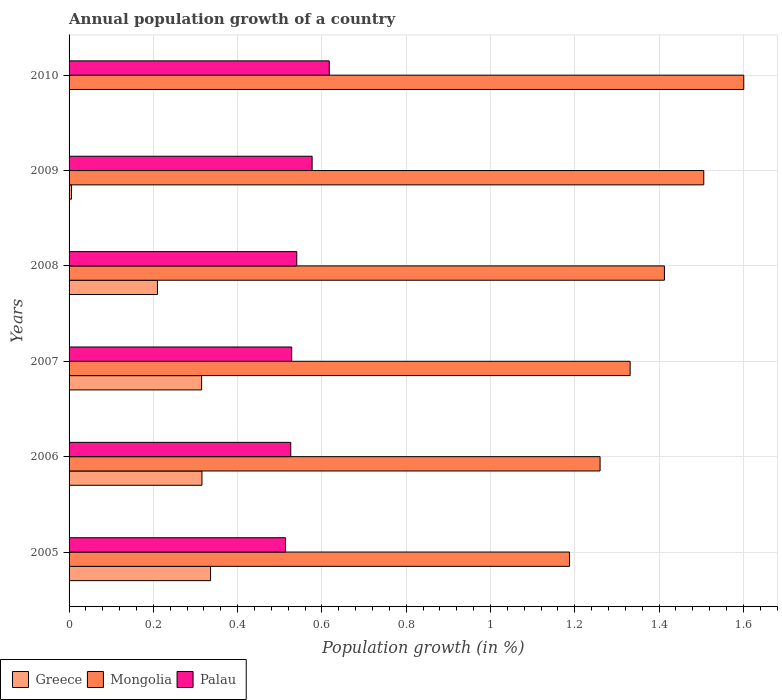How many groups of bars are there?
Provide a succinct answer. 6. How many bars are there on the 2nd tick from the bottom?
Offer a terse response. 3. In how many cases, is the number of bars for a given year not equal to the number of legend labels?
Your answer should be compact. 1. What is the annual population growth in Mongolia in 2010?
Offer a very short reply. 1.6. Across all years, what is the maximum annual population growth in Mongolia?
Your response must be concise. 1.6. Across all years, what is the minimum annual population growth in Mongolia?
Give a very brief answer. 1.19. What is the total annual population growth in Mongolia in the graph?
Make the answer very short. 8.3. What is the difference between the annual population growth in Greece in 2006 and that in 2008?
Ensure brevity in your answer.  0.11. What is the difference between the annual population growth in Palau in 2010 and the annual population growth in Mongolia in 2008?
Provide a short and direct response. -0.8. What is the average annual population growth in Mongolia per year?
Offer a very short reply. 1.38. In the year 2005, what is the difference between the annual population growth in Greece and annual population growth in Mongolia?
Offer a terse response. -0.85. In how many years, is the annual population growth in Greece greater than 0.48000000000000004 %?
Your answer should be very brief. 0. What is the ratio of the annual population growth in Greece in 2005 to that in 2006?
Make the answer very short. 1.06. Is the annual population growth in Palau in 2005 less than that in 2008?
Ensure brevity in your answer.  Yes. What is the difference between the highest and the second highest annual population growth in Greece?
Provide a short and direct response. 0.02. What is the difference between the highest and the lowest annual population growth in Palau?
Your answer should be compact. 0.1. In how many years, is the annual population growth in Palau greater than the average annual population growth in Palau taken over all years?
Offer a terse response. 2. Is the sum of the annual population growth in Mongolia in 2006 and 2009 greater than the maximum annual population growth in Palau across all years?
Keep it short and to the point. Yes. Are all the bars in the graph horizontal?
Offer a very short reply. Yes. What is the difference between two consecutive major ticks on the X-axis?
Your answer should be compact. 0.2. Are the values on the major ticks of X-axis written in scientific E-notation?
Keep it short and to the point. No. How are the legend labels stacked?
Give a very brief answer. Horizontal. What is the title of the graph?
Keep it short and to the point. Annual population growth of a country. Does "Malta" appear as one of the legend labels in the graph?
Offer a very short reply. No. What is the label or title of the X-axis?
Make the answer very short. Population growth (in %). What is the label or title of the Y-axis?
Provide a succinct answer. Years. What is the Population growth (in %) in Greece in 2005?
Offer a terse response. 0.34. What is the Population growth (in %) in Mongolia in 2005?
Make the answer very short. 1.19. What is the Population growth (in %) of Palau in 2005?
Offer a terse response. 0.51. What is the Population growth (in %) of Greece in 2006?
Offer a very short reply. 0.32. What is the Population growth (in %) of Mongolia in 2006?
Keep it short and to the point. 1.26. What is the Population growth (in %) of Palau in 2006?
Ensure brevity in your answer.  0.53. What is the Population growth (in %) in Greece in 2007?
Your answer should be very brief. 0.31. What is the Population growth (in %) in Mongolia in 2007?
Provide a succinct answer. 1.33. What is the Population growth (in %) in Palau in 2007?
Provide a succinct answer. 0.53. What is the Population growth (in %) of Greece in 2008?
Give a very brief answer. 0.21. What is the Population growth (in %) in Mongolia in 2008?
Your answer should be compact. 1.41. What is the Population growth (in %) of Palau in 2008?
Provide a succinct answer. 0.54. What is the Population growth (in %) in Greece in 2009?
Make the answer very short. 0.01. What is the Population growth (in %) of Mongolia in 2009?
Offer a terse response. 1.51. What is the Population growth (in %) of Palau in 2009?
Offer a very short reply. 0.58. What is the Population growth (in %) in Greece in 2010?
Your answer should be very brief. 0. What is the Population growth (in %) of Mongolia in 2010?
Your answer should be compact. 1.6. What is the Population growth (in %) of Palau in 2010?
Your answer should be very brief. 0.62. Across all years, what is the maximum Population growth (in %) in Greece?
Your response must be concise. 0.34. Across all years, what is the maximum Population growth (in %) of Mongolia?
Give a very brief answer. 1.6. Across all years, what is the maximum Population growth (in %) of Palau?
Give a very brief answer. 0.62. Across all years, what is the minimum Population growth (in %) of Mongolia?
Your response must be concise. 1.19. Across all years, what is the minimum Population growth (in %) of Palau?
Provide a short and direct response. 0.51. What is the total Population growth (in %) in Greece in the graph?
Your answer should be very brief. 1.18. What is the total Population growth (in %) in Mongolia in the graph?
Keep it short and to the point. 8.3. What is the total Population growth (in %) of Palau in the graph?
Your response must be concise. 3.3. What is the difference between the Population growth (in %) in Greece in 2005 and that in 2006?
Your answer should be very brief. 0.02. What is the difference between the Population growth (in %) of Mongolia in 2005 and that in 2006?
Make the answer very short. -0.07. What is the difference between the Population growth (in %) in Palau in 2005 and that in 2006?
Give a very brief answer. -0.01. What is the difference between the Population growth (in %) in Greece in 2005 and that in 2007?
Make the answer very short. 0.02. What is the difference between the Population growth (in %) of Mongolia in 2005 and that in 2007?
Give a very brief answer. -0.14. What is the difference between the Population growth (in %) of Palau in 2005 and that in 2007?
Keep it short and to the point. -0.01. What is the difference between the Population growth (in %) in Greece in 2005 and that in 2008?
Your answer should be compact. 0.13. What is the difference between the Population growth (in %) in Mongolia in 2005 and that in 2008?
Offer a terse response. -0.23. What is the difference between the Population growth (in %) in Palau in 2005 and that in 2008?
Provide a short and direct response. -0.03. What is the difference between the Population growth (in %) of Greece in 2005 and that in 2009?
Your answer should be very brief. 0.33. What is the difference between the Population growth (in %) in Mongolia in 2005 and that in 2009?
Ensure brevity in your answer.  -0.32. What is the difference between the Population growth (in %) in Palau in 2005 and that in 2009?
Your answer should be very brief. -0.06. What is the difference between the Population growth (in %) of Mongolia in 2005 and that in 2010?
Your response must be concise. -0.41. What is the difference between the Population growth (in %) of Palau in 2005 and that in 2010?
Your answer should be compact. -0.1. What is the difference between the Population growth (in %) of Greece in 2006 and that in 2007?
Your response must be concise. 0. What is the difference between the Population growth (in %) in Mongolia in 2006 and that in 2007?
Your answer should be very brief. -0.07. What is the difference between the Population growth (in %) in Palau in 2006 and that in 2007?
Your response must be concise. -0. What is the difference between the Population growth (in %) in Greece in 2006 and that in 2008?
Make the answer very short. 0.11. What is the difference between the Population growth (in %) in Mongolia in 2006 and that in 2008?
Your response must be concise. -0.15. What is the difference between the Population growth (in %) of Palau in 2006 and that in 2008?
Make the answer very short. -0.01. What is the difference between the Population growth (in %) of Greece in 2006 and that in 2009?
Provide a succinct answer. 0.31. What is the difference between the Population growth (in %) of Mongolia in 2006 and that in 2009?
Provide a short and direct response. -0.25. What is the difference between the Population growth (in %) in Palau in 2006 and that in 2009?
Make the answer very short. -0.05. What is the difference between the Population growth (in %) in Mongolia in 2006 and that in 2010?
Give a very brief answer. -0.34. What is the difference between the Population growth (in %) in Palau in 2006 and that in 2010?
Your answer should be compact. -0.09. What is the difference between the Population growth (in %) in Greece in 2007 and that in 2008?
Make the answer very short. 0.1. What is the difference between the Population growth (in %) in Mongolia in 2007 and that in 2008?
Make the answer very short. -0.08. What is the difference between the Population growth (in %) of Palau in 2007 and that in 2008?
Offer a terse response. -0.01. What is the difference between the Population growth (in %) of Greece in 2007 and that in 2009?
Offer a very short reply. 0.31. What is the difference between the Population growth (in %) in Mongolia in 2007 and that in 2009?
Keep it short and to the point. -0.17. What is the difference between the Population growth (in %) of Palau in 2007 and that in 2009?
Provide a succinct answer. -0.05. What is the difference between the Population growth (in %) in Mongolia in 2007 and that in 2010?
Ensure brevity in your answer.  -0.27. What is the difference between the Population growth (in %) in Palau in 2007 and that in 2010?
Offer a terse response. -0.09. What is the difference between the Population growth (in %) of Greece in 2008 and that in 2009?
Your answer should be compact. 0.2. What is the difference between the Population growth (in %) of Mongolia in 2008 and that in 2009?
Offer a terse response. -0.09. What is the difference between the Population growth (in %) in Palau in 2008 and that in 2009?
Ensure brevity in your answer.  -0.04. What is the difference between the Population growth (in %) in Mongolia in 2008 and that in 2010?
Make the answer very short. -0.19. What is the difference between the Population growth (in %) of Palau in 2008 and that in 2010?
Offer a terse response. -0.08. What is the difference between the Population growth (in %) of Mongolia in 2009 and that in 2010?
Keep it short and to the point. -0.09. What is the difference between the Population growth (in %) of Palau in 2009 and that in 2010?
Your response must be concise. -0.04. What is the difference between the Population growth (in %) in Greece in 2005 and the Population growth (in %) in Mongolia in 2006?
Ensure brevity in your answer.  -0.92. What is the difference between the Population growth (in %) of Greece in 2005 and the Population growth (in %) of Palau in 2006?
Offer a very short reply. -0.19. What is the difference between the Population growth (in %) of Mongolia in 2005 and the Population growth (in %) of Palau in 2006?
Offer a very short reply. 0.66. What is the difference between the Population growth (in %) of Greece in 2005 and the Population growth (in %) of Mongolia in 2007?
Your answer should be compact. -1. What is the difference between the Population growth (in %) of Greece in 2005 and the Population growth (in %) of Palau in 2007?
Offer a very short reply. -0.19. What is the difference between the Population growth (in %) in Mongolia in 2005 and the Population growth (in %) in Palau in 2007?
Make the answer very short. 0.66. What is the difference between the Population growth (in %) in Greece in 2005 and the Population growth (in %) in Mongolia in 2008?
Give a very brief answer. -1.08. What is the difference between the Population growth (in %) of Greece in 2005 and the Population growth (in %) of Palau in 2008?
Make the answer very short. -0.2. What is the difference between the Population growth (in %) of Mongolia in 2005 and the Population growth (in %) of Palau in 2008?
Your answer should be very brief. 0.65. What is the difference between the Population growth (in %) in Greece in 2005 and the Population growth (in %) in Mongolia in 2009?
Your response must be concise. -1.17. What is the difference between the Population growth (in %) of Greece in 2005 and the Population growth (in %) of Palau in 2009?
Your response must be concise. -0.24. What is the difference between the Population growth (in %) of Mongolia in 2005 and the Population growth (in %) of Palau in 2009?
Give a very brief answer. 0.61. What is the difference between the Population growth (in %) in Greece in 2005 and the Population growth (in %) in Mongolia in 2010?
Make the answer very short. -1.27. What is the difference between the Population growth (in %) in Greece in 2005 and the Population growth (in %) in Palau in 2010?
Provide a succinct answer. -0.28. What is the difference between the Population growth (in %) in Mongolia in 2005 and the Population growth (in %) in Palau in 2010?
Keep it short and to the point. 0.57. What is the difference between the Population growth (in %) in Greece in 2006 and the Population growth (in %) in Mongolia in 2007?
Provide a succinct answer. -1.02. What is the difference between the Population growth (in %) of Greece in 2006 and the Population growth (in %) of Palau in 2007?
Keep it short and to the point. -0.21. What is the difference between the Population growth (in %) of Mongolia in 2006 and the Population growth (in %) of Palau in 2007?
Provide a short and direct response. 0.73. What is the difference between the Population growth (in %) in Greece in 2006 and the Population growth (in %) in Mongolia in 2008?
Offer a very short reply. -1.1. What is the difference between the Population growth (in %) in Greece in 2006 and the Population growth (in %) in Palau in 2008?
Offer a terse response. -0.23. What is the difference between the Population growth (in %) in Mongolia in 2006 and the Population growth (in %) in Palau in 2008?
Your answer should be very brief. 0.72. What is the difference between the Population growth (in %) of Greece in 2006 and the Population growth (in %) of Mongolia in 2009?
Offer a very short reply. -1.19. What is the difference between the Population growth (in %) of Greece in 2006 and the Population growth (in %) of Palau in 2009?
Offer a terse response. -0.26. What is the difference between the Population growth (in %) of Mongolia in 2006 and the Population growth (in %) of Palau in 2009?
Make the answer very short. 0.68. What is the difference between the Population growth (in %) of Greece in 2006 and the Population growth (in %) of Mongolia in 2010?
Keep it short and to the point. -1.29. What is the difference between the Population growth (in %) in Greece in 2006 and the Population growth (in %) in Palau in 2010?
Keep it short and to the point. -0.3. What is the difference between the Population growth (in %) in Mongolia in 2006 and the Population growth (in %) in Palau in 2010?
Keep it short and to the point. 0.64. What is the difference between the Population growth (in %) in Greece in 2007 and the Population growth (in %) in Mongolia in 2008?
Make the answer very short. -1.1. What is the difference between the Population growth (in %) in Greece in 2007 and the Population growth (in %) in Palau in 2008?
Your answer should be very brief. -0.23. What is the difference between the Population growth (in %) of Mongolia in 2007 and the Population growth (in %) of Palau in 2008?
Make the answer very short. 0.79. What is the difference between the Population growth (in %) of Greece in 2007 and the Population growth (in %) of Mongolia in 2009?
Give a very brief answer. -1.19. What is the difference between the Population growth (in %) in Greece in 2007 and the Population growth (in %) in Palau in 2009?
Your response must be concise. -0.26. What is the difference between the Population growth (in %) in Mongolia in 2007 and the Population growth (in %) in Palau in 2009?
Keep it short and to the point. 0.75. What is the difference between the Population growth (in %) in Greece in 2007 and the Population growth (in %) in Mongolia in 2010?
Make the answer very short. -1.29. What is the difference between the Population growth (in %) of Greece in 2007 and the Population growth (in %) of Palau in 2010?
Your answer should be compact. -0.3. What is the difference between the Population growth (in %) in Mongolia in 2007 and the Population growth (in %) in Palau in 2010?
Provide a succinct answer. 0.71. What is the difference between the Population growth (in %) of Greece in 2008 and the Population growth (in %) of Mongolia in 2009?
Provide a succinct answer. -1.3. What is the difference between the Population growth (in %) in Greece in 2008 and the Population growth (in %) in Palau in 2009?
Provide a succinct answer. -0.37. What is the difference between the Population growth (in %) of Mongolia in 2008 and the Population growth (in %) of Palau in 2009?
Offer a terse response. 0.84. What is the difference between the Population growth (in %) in Greece in 2008 and the Population growth (in %) in Mongolia in 2010?
Your response must be concise. -1.39. What is the difference between the Population growth (in %) of Greece in 2008 and the Population growth (in %) of Palau in 2010?
Offer a very short reply. -0.41. What is the difference between the Population growth (in %) in Mongolia in 2008 and the Population growth (in %) in Palau in 2010?
Your response must be concise. 0.8. What is the difference between the Population growth (in %) of Greece in 2009 and the Population growth (in %) of Mongolia in 2010?
Give a very brief answer. -1.6. What is the difference between the Population growth (in %) in Greece in 2009 and the Population growth (in %) in Palau in 2010?
Provide a succinct answer. -0.61. What is the difference between the Population growth (in %) of Mongolia in 2009 and the Population growth (in %) of Palau in 2010?
Your response must be concise. 0.89. What is the average Population growth (in %) of Greece per year?
Keep it short and to the point. 0.2. What is the average Population growth (in %) in Mongolia per year?
Your response must be concise. 1.38. What is the average Population growth (in %) in Palau per year?
Offer a terse response. 0.55. In the year 2005, what is the difference between the Population growth (in %) of Greece and Population growth (in %) of Mongolia?
Offer a terse response. -0.85. In the year 2005, what is the difference between the Population growth (in %) of Greece and Population growth (in %) of Palau?
Provide a succinct answer. -0.18. In the year 2005, what is the difference between the Population growth (in %) of Mongolia and Population growth (in %) of Palau?
Keep it short and to the point. 0.67. In the year 2006, what is the difference between the Population growth (in %) of Greece and Population growth (in %) of Mongolia?
Give a very brief answer. -0.94. In the year 2006, what is the difference between the Population growth (in %) in Greece and Population growth (in %) in Palau?
Your response must be concise. -0.21. In the year 2006, what is the difference between the Population growth (in %) of Mongolia and Population growth (in %) of Palau?
Offer a terse response. 0.73. In the year 2007, what is the difference between the Population growth (in %) in Greece and Population growth (in %) in Mongolia?
Make the answer very short. -1.02. In the year 2007, what is the difference between the Population growth (in %) of Greece and Population growth (in %) of Palau?
Your response must be concise. -0.21. In the year 2007, what is the difference between the Population growth (in %) in Mongolia and Population growth (in %) in Palau?
Provide a succinct answer. 0.8. In the year 2008, what is the difference between the Population growth (in %) of Greece and Population growth (in %) of Mongolia?
Provide a short and direct response. -1.2. In the year 2008, what is the difference between the Population growth (in %) in Greece and Population growth (in %) in Palau?
Give a very brief answer. -0.33. In the year 2008, what is the difference between the Population growth (in %) of Mongolia and Population growth (in %) of Palau?
Your answer should be very brief. 0.87. In the year 2009, what is the difference between the Population growth (in %) in Greece and Population growth (in %) in Mongolia?
Ensure brevity in your answer.  -1.5. In the year 2009, what is the difference between the Population growth (in %) of Greece and Population growth (in %) of Palau?
Give a very brief answer. -0.57. In the year 2009, what is the difference between the Population growth (in %) of Mongolia and Population growth (in %) of Palau?
Provide a succinct answer. 0.93. In the year 2010, what is the difference between the Population growth (in %) of Mongolia and Population growth (in %) of Palau?
Your answer should be very brief. 0.98. What is the ratio of the Population growth (in %) of Greece in 2005 to that in 2006?
Your answer should be compact. 1.06. What is the ratio of the Population growth (in %) of Mongolia in 2005 to that in 2006?
Provide a succinct answer. 0.94. What is the ratio of the Population growth (in %) in Palau in 2005 to that in 2006?
Keep it short and to the point. 0.98. What is the ratio of the Population growth (in %) in Greece in 2005 to that in 2007?
Your answer should be compact. 1.07. What is the ratio of the Population growth (in %) of Mongolia in 2005 to that in 2007?
Provide a short and direct response. 0.89. What is the ratio of the Population growth (in %) of Palau in 2005 to that in 2007?
Ensure brevity in your answer.  0.97. What is the ratio of the Population growth (in %) in Greece in 2005 to that in 2008?
Offer a very short reply. 1.6. What is the ratio of the Population growth (in %) of Mongolia in 2005 to that in 2008?
Your response must be concise. 0.84. What is the ratio of the Population growth (in %) in Palau in 2005 to that in 2008?
Your answer should be compact. 0.95. What is the ratio of the Population growth (in %) in Greece in 2005 to that in 2009?
Keep it short and to the point. 58.14. What is the ratio of the Population growth (in %) of Mongolia in 2005 to that in 2009?
Your response must be concise. 0.79. What is the ratio of the Population growth (in %) of Palau in 2005 to that in 2009?
Your answer should be very brief. 0.89. What is the ratio of the Population growth (in %) of Mongolia in 2005 to that in 2010?
Provide a succinct answer. 0.74. What is the ratio of the Population growth (in %) of Palau in 2005 to that in 2010?
Your answer should be very brief. 0.83. What is the ratio of the Population growth (in %) of Mongolia in 2006 to that in 2007?
Provide a short and direct response. 0.95. What is the ratio of the Population growth (in %) in Palau in 2006 to that in 2007?
Give a very brief answer. 1. What is the ratio of the Population growth (in %) in Greece in 2006 to that in 2008?
Offer a very short reply. 1.5. What is the ratio of the Population growth (in %) in Mongolia in 2006 to that in 2008?
Ensure brevity in your answer.  0.89. What is the ratio of the Population growth (in %) of Palau in 2006 to that in 2008?
Ensure brevity in your answer.  0.97. What is the ratio of the Population growth (in %) of Greece in 2006 to that in 2009?
Make the answer very short. 54.6. What is the ratio of the Population growth (in %) of Mongolia in 2006 to that in 2009?
Your answer should be very brief. 0.84. What is the ratio of the Population growth (in %) in Palau in 2006 to that in 2009?
Offer a terse response. 0.91. What is the ratio of the Population growth (in %) in Mongolia in 2006 to that in 2010?
Your answer should be very brief. 0.79. What is the ratio of the Population growth (in %) of Palau in 2006 to that in 2010?
Make the answer very short. 0.85. What is the ratio of the Population growth (in %) of Greece in 2007 to that in 2008?
Your response must be concise. 1.5. What is the ratio of the Population growth (in %) of Mongolia in 2007 to that in 2008?
Your answer should be compact. 0.94. What is the ratio of the Population growth (in %) of Palau in 2007 to that in 2008?
Provide a short and direct response. 0.98. What is the ratio of the Population growth (in %) of Greece in 2007 to that in 2009?
Your response must be concise. 54.47. What is the ratio of the Population growth (in %) of Mongolia in 2007 to that in 2009?
Keep it short and to the point. 0.88. What is the ratio of the Population growth (in %) of Palau in 2007 to that in 2009?
Make the answer very short. 0.92. What is the ratio of the Population growth (in %) in Mongolia in 2007 to that in 2010?
Your response must be concise. 0.83. What is the ratio of the Population growth (in %) of Palau in 2007 to that in 2010?
Give a very brief answer. 0.86. What is the ratio of the Population growth (in %) in Greece in 2008 to that in 2009?
Ensure brevity in your answer.  36.32. What is the ratio of the Population growth (in %) in Mongolia in 2008 to that in 2009?
Keep it short and to the point. 0.94. What is the ratio of the Population growth (in %) in Palau in 2008 to that in 2009?
Offer a very short reply. 0.94. What is the ratio of the Population growth (in %) in Mongolia in 2008 to that in 2010?
Make the answer very short. 0.88. What is the ratio of the Population growth (in %) in Palau in 2008 to that in 2010?
Your response must be concise. 0.88. What is the ratio of the Population growth (in %) in Mongolia in 2009 to that in 2010?
Provide a succinct answer. 0.94. What is the ratio of the Population growth (in %) in Palau in 2009 to that in 2010?
Provide a succinct answer. 0.93. What is the difference between the highest and the second highest Population growth (in %) in Greece?
Make the answer very short. 0.02. What is the difference between the highest and the second highest Population growth (in %) in Mongolia?
Your answer should be very brief. 0.09. What is the difference between the highest and the second highest Population growth (in %) in Palau?
Offer a very short reply. 0.04. What is the difference between the highest and the lowest Population growth (in %) of Greece?
Your answer should be compact. 0.34. What is the difference between the highest and the lowest Population growth (in %) of Mongolia?
Your answer should be very brief. 0.41. What is the difference between the highest and the lowest Population growth (in %) in Palau?
Keep it short and to the point. 0.1. 